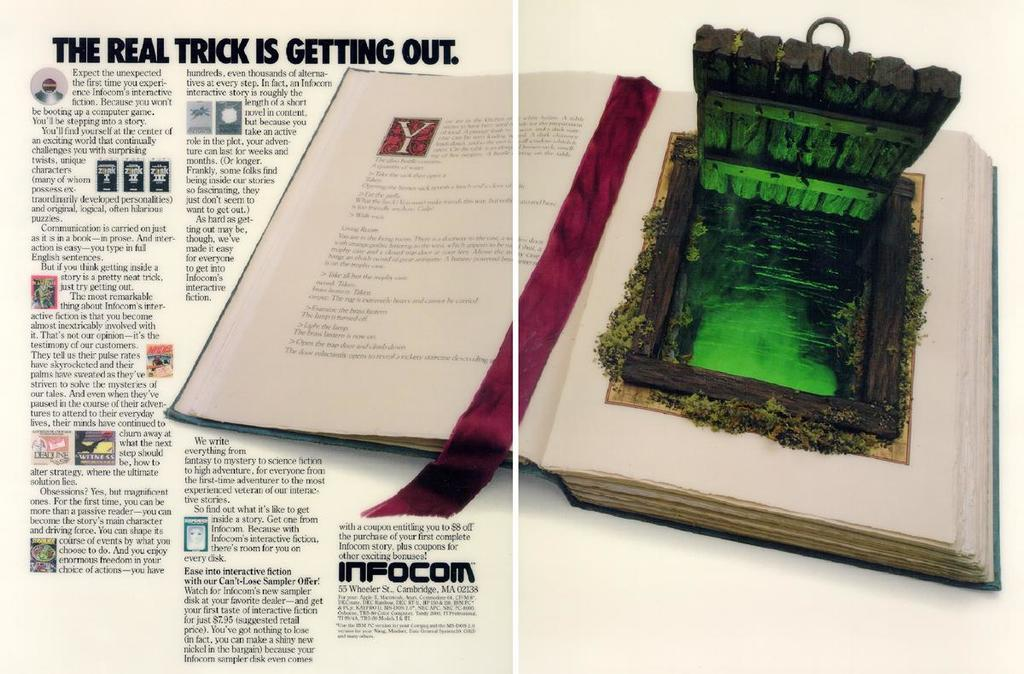<image>
Provide a brief description of the given image. An interactive book is displayed in an advertisement for infocom where The Real Trick is Getting Out. 